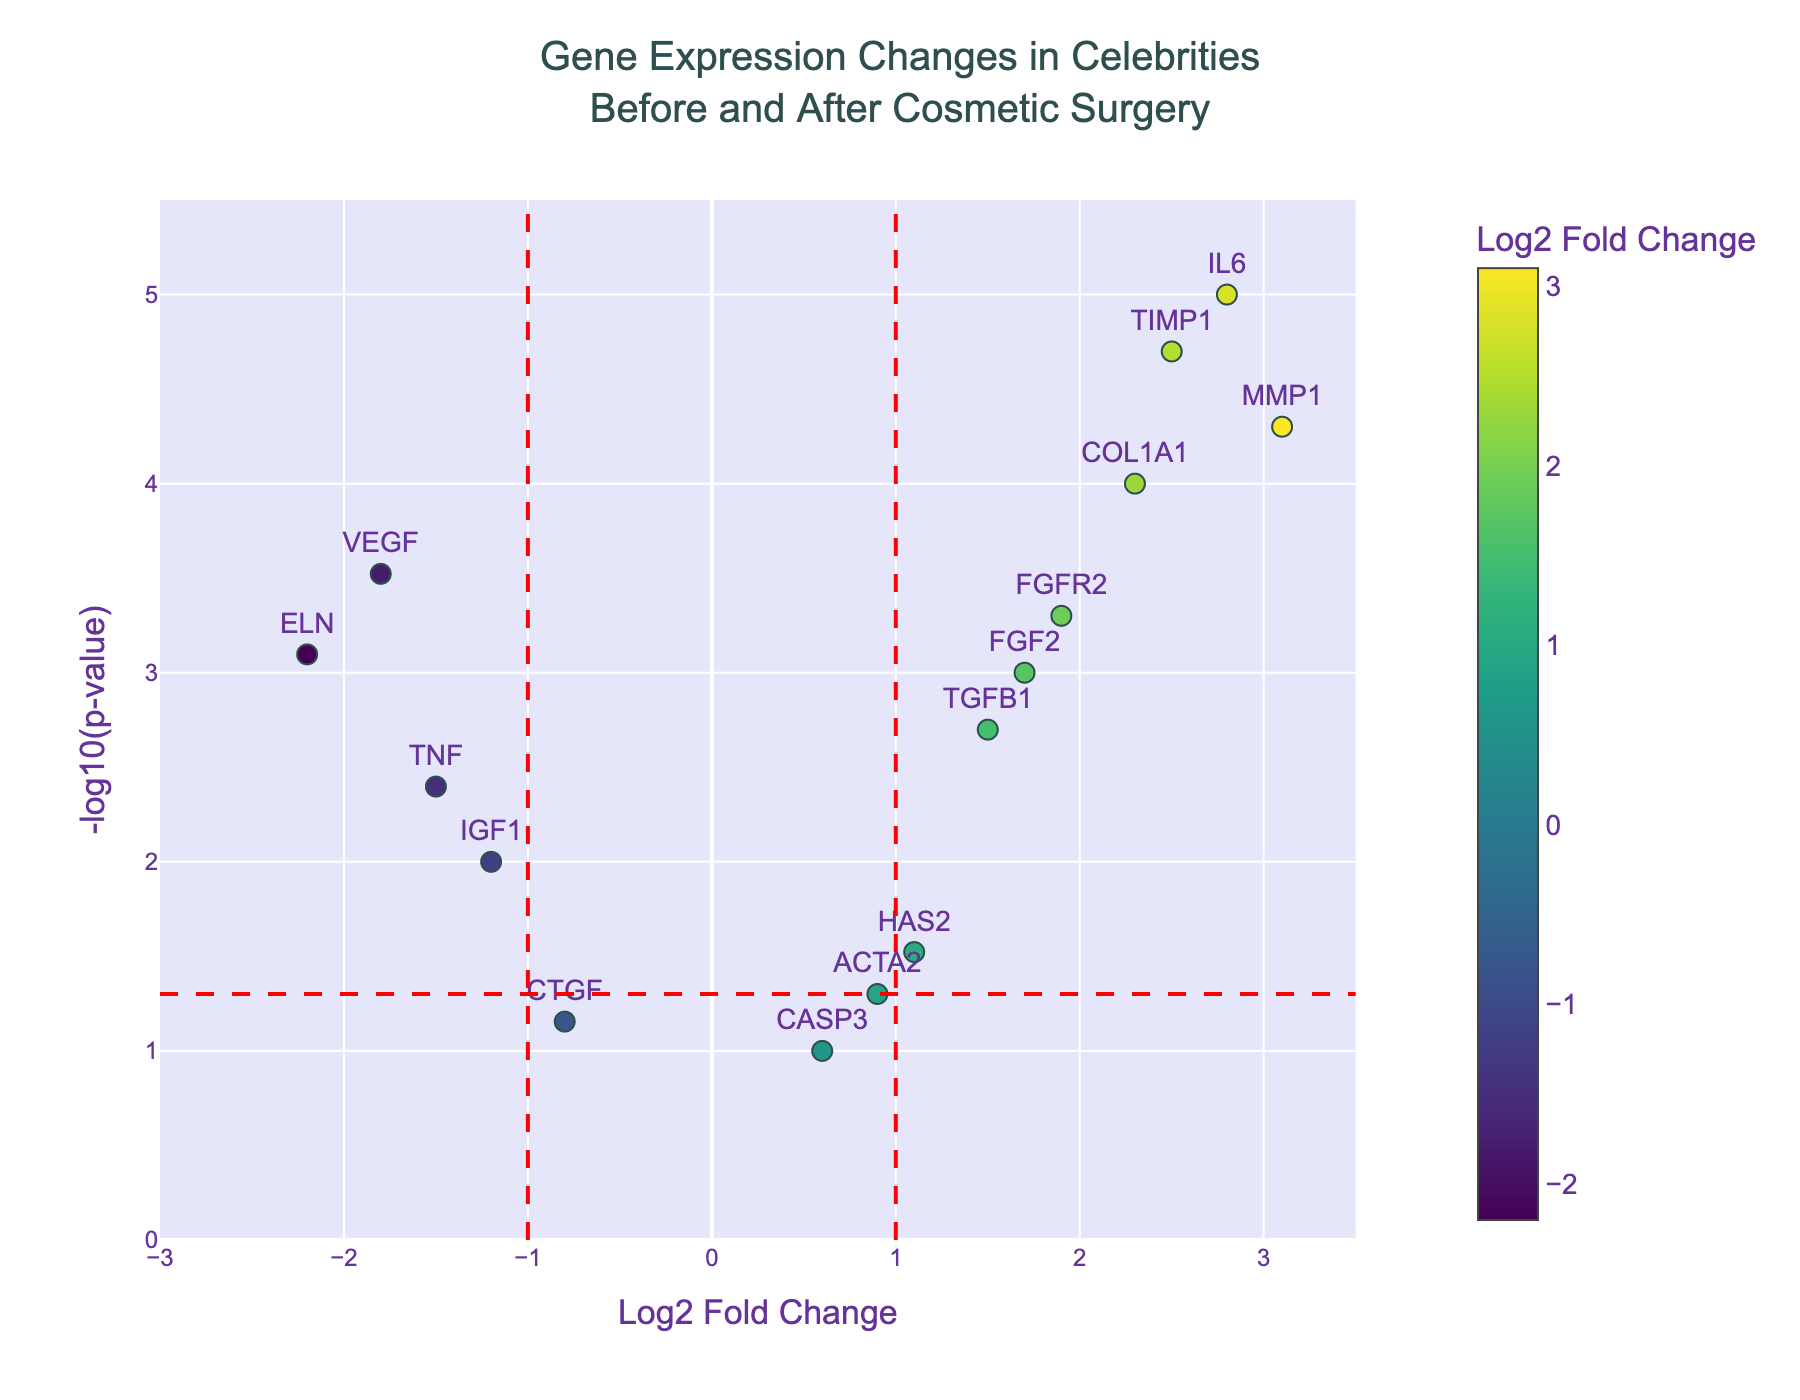What is the title of the plot? The title of the plot is visible at the top center of the figure.
Answer: Gene Expression Changes in Celebrities Before and After Cosmetic Surgery How many genes are significantly changed (p-value < 0.05) after cosmetic surgery? To find significantly changed genes, look for data points above the horizontal red line indicating p-value < 0.05. Count these points.
Answer: 11 Which gene has the highest log2 fold change? The gene with the highest log2 fold change is the one with the largest positive x-axis value.
Answer: MMP1 What do the red dashed lines represent? The vertical and horizontal red dashed lines mark thresholds. The vertical lines at log2 fold change = ±1 and the horizontal line at -log10(p-value) = 1.3 (0.05) define significance thresholds.
Answer: Significance thresholds What is the range of the values on the x-axis (Log2 Fold Change)? Observe the minimum and maximum x-axis values displayed. They range from -3 to 3.5.
Answer: -3 to 3.5 How many genes have a log2 fold change greater than 1? Count the genes with log2 fold change values greater than 1 by observing the x-axis.
Answer: 6 Which gene has a lower p-value: ELN or VEGF? Compare the y-coordinates (-log10 of the p-value) of ELN and VEGF; the gene higher up has a lower p-value.
Answer: VEGF Which genes have a negative log2 fold change and are significantly changed (p-value < 0.05)? Look for genes to the left of the vertical line at -1 and above the horizontal line (p-value < 0.05).
Answer: VEGF, ELN, TNF Which genes are upregulated (positive log2 fold change) and have a p-value < 0.001? Look for genes to the right of the vertical line at 1 and above the horizontal threshold (p-value < 0.001).
Answer: COL1A1, MMP1, TIMP1, IL6 